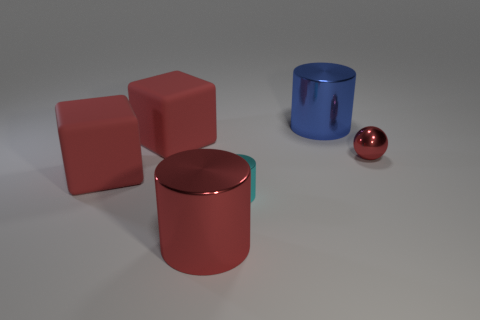Is the number of tiny metallic cylinders that are on the left side of the red sphere greater than the number of large red matte things on the right side of the large red cylinder?
Your response must be concise. Yes. There is a red metallic thing that is the same size as the blue thing; what is its shape?
Provide a short and direct response. Cylinder. There is a tiny object that is made of the same material as the cyan cylinder; what color is it?
Provide a short and direct response. Red. There is a big metal object that is left of the blue cylinder; does it have the same color as the ball?
Provide a short and direct response. Yes. There is a rubber cube in front of the metal object that is on the right side of the blue shiny thing; what is its size?
Provide a short and direct response. Large. How many other large objects are the same material as the large blue object?
Give a very brief answer. 1. What size is the cyan thing that is the same shape as the big red metallic object?
Provide a succinct answer. Small. What material is the big red block that is in front of the thing on the right side of the big cylinder that is behind the tiny cyan shiny cylinder made of?
Provide a succinct answer. Rubber. Is there anything else that has the same shape as the tiny red thing?
Make the answer very short. No. The other big object that is the same shape as the blue metal thing is what color?
Your answer should be compact. Red. 